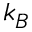<formula> <loc_0><loc_0><loc_500><loc_500>k _ { B }</formula> 